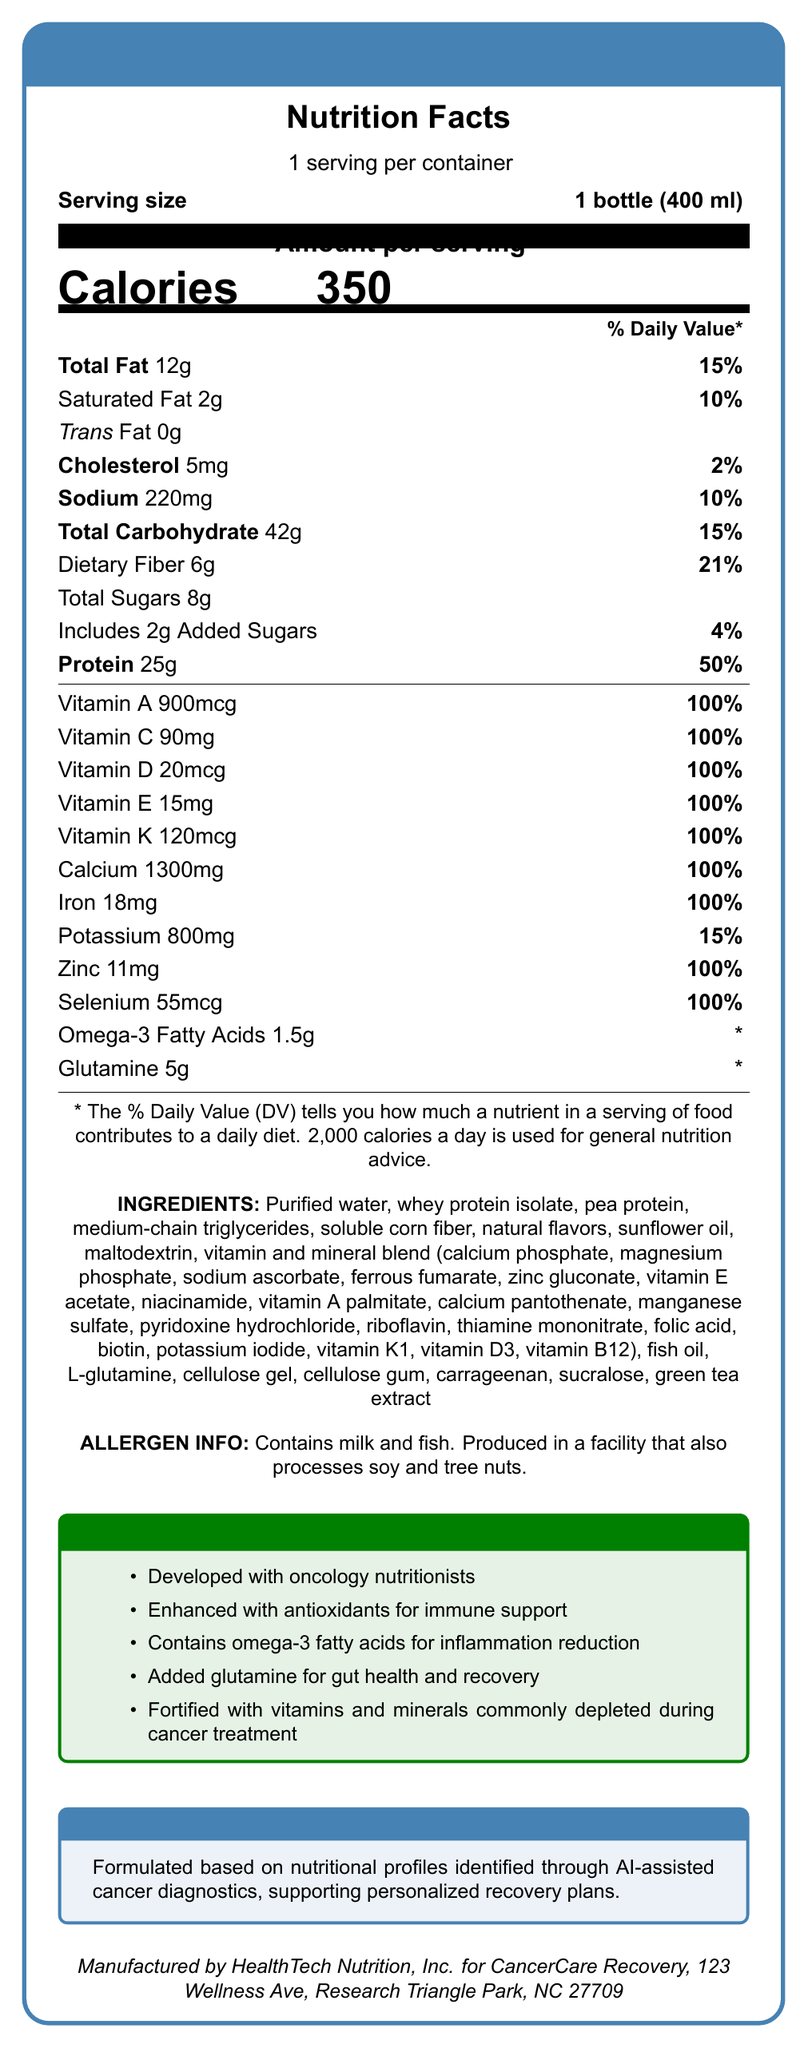what is the serving size of the CancerCare Recovery Shake? The document specifies that the serving size is "1 bottle (400 ml)."
Answer: 1 bottle (400 ml) how many calories are in one serving of the CancerCare Recovery Shake? The document states that there are 350 calories per serving.
Answer: 350 what percentage of the Daily Value (DV) for protein does one serving provide? The label shows that one serving of the shake provides 25g of protein, which is 50% of the Daily Value.
Answer: 50% what are the special features highlighted in the document? List at least two. The document lists these as part of the special features: "Developed with oncology nutritionists" and "Enhanced with antioxidants for immune support."
Answer: Developed with oncology nutritionists and Enhanced with antioxidants for immune support how much dietary fiber is in one serving, and what is its percent Daily Value? The nutritional facts indicate that one serving contains 6g of dietary fiber, which is 21% of the Daily Value.
Answer: 6g, 21% what type of fat is completely absent in the CancerCare Recovery Shake? The document shows that Trans Fat is listed as 0g.
Answer: Trans Fat how much vitamin D is in one serving of the shake? The nutrition facts label shows that one serving contains 20mcg of vitamin D.
Answer: 20mcg is the CancerCare Recovery Shake allergen-free? The document specifies that the shake contains milk and fish and is produced in a facility that processes soy and tree nuts.
Answer: No what is the concentration of iron in one serving of the product? The document shows 18mg of iron per serving, which is 100% of the Daily Value.
Answer: 18mg how does the AI diagnostics statement describe the formulation of the shake? The AI diagnostic statement in the document mentions that the shake is formulated based on nutritional profiles identified through AI-assisted cancer diagnostics, supporting personalized recovery plans.
Answer: Formulated based on nutritional profiles identified through AI-assisted cancer diagnostics, supporting personalized recovery plans. which vitamin is provided at 100% of the DV per serving? A. Vitamin A B. Vitamin C C. Vitamin D D. All of the above The label shows that Vitamin A, Vitamin C, and Vitamin D are all provided at 100% of the DV.
Answer: D. All of the above which ingredient is not part of the CancerCare Recovery Shake? A. Whey Protein Isolate B. Rice Protein C. Fish Oil D. Soluble Corn Fiber The ingredients list includes Whey Protein Isolate, Fish Oil, and Soluble Corn Fiber but does not mention Rice Protein.
Answer: B. Rice Protein does the CancerCare Recovery Shake include added sugars? The document states that the shake contains 2g of added sugars, which makes up 4% of the Daily Value.
Answer: Yes describe the main idea of the document. The label provides detailed information about the nutritional content, ingredients, and special features of the CancerCare Recovery Shake, emphasizing its tailored formulation for post-cancer recovery.
Answer: The document is the Nutrition Facts Label for the CancerCare Recovery Shake, which is a meal replacement tailored for post-cancer recovery. It is developed with oncology nutritionists, is enhanced with antioxidants for immune support, contains omega-3 fatty acids for inflammation reduction, and added glutamine for gut health and recovery. It is fortified with vitamins and minerals commonly depleted during cancer treatment. The formulation is based on AI-assisted cancer diagnostics. what are the exact amounts of omega-3 fatty acids and glutamine in one serving of the shake? The nutritional facts specify that one serving includes 1.5g of omega-3 fatty acids and 5g of glutamine.
Answer: Omega-3 Fatty Acids: 1.5g, Glutamine: 5g how many servings are there in one container of the CancerCare Recovery Shake? The document clearly states that there is 1 serving per container.
Answer: 1 where is the CancerCare Recovery Shake manufactured? The document lists this address as the manufacturer's information.
Answer: HealthTech Nutrition, Inc. for CancerCare Recovery, 123 Wellness Ave, Research Triangle Park, NC 27709 how many mg of potassium are in one serving, and what is its percent Daily Value? The nutritional facts label shows that one serving contains 800mg of potassium, which is 15% of the Daily Value.
Answer: 800mg, 15% is soluble corn fiber one of the ingredients in the CancerCare Recovery Shake? The ingredients list includes soluble corn fiber.
Answer: Yes what is the exact AI diagnostic statement mentioned in the document? The document mentions this exact AI diagnostic statement.
Answer: Formulated based on nutritional profiles identified through AI-assisted cancer diagnostics, supporting personalized recovery plans. 